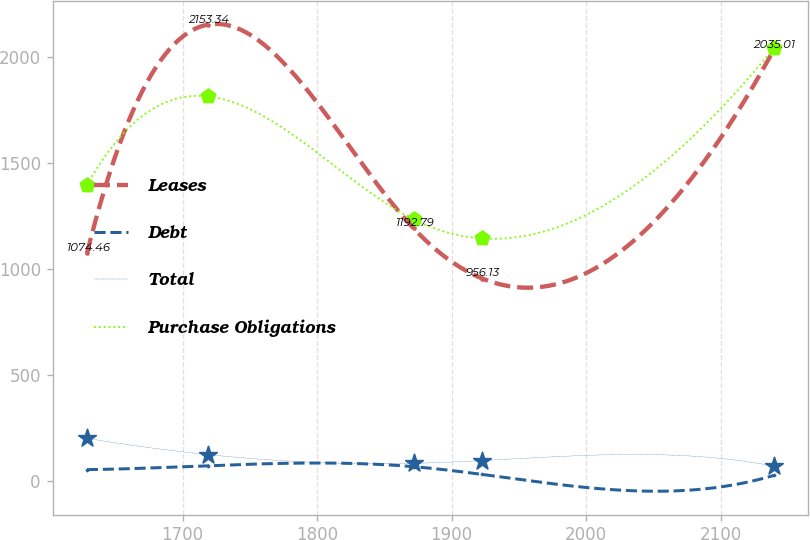Convert chart. <chart><loc_0><loc_0><loc_500><loc_500><line_chart><ecel><fcel>Leases<fcel>Debt<fcel>Total<fcel>Purchase Obligations<nl><fcel>1628.8<fcel>1074.46<fcel>55.39<fcel>202.79<fcel>1396.17<nl><fcel>1718.84<fcel>2153.34<fcel>73.84<fcel>126.26<fcel>1814.89<nl><fcel>1871.79<fcel>1192.79<fcel>69.35<fcel>85.19<fcel>1235.04<nl><fcel>1922.87<fcel>956.13<fcel>32.74<fcel>98.26<fcel>1145.38<nl><fcel>2139.55<fcel>2035.01<fcel>28.25<fcel>72.12<fcel>2042<nl></chart> 